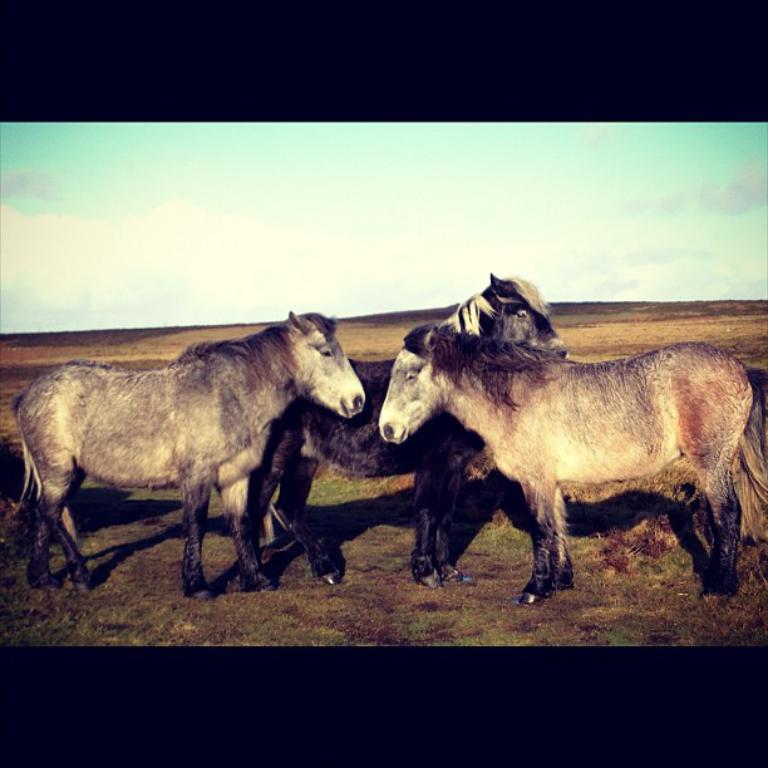Could you give a brief overview of what you see in this image? This picture is an edited picture. In this picture there are three horses standing. At the top there is sky and there are clouds. At the bottom there is grass. 